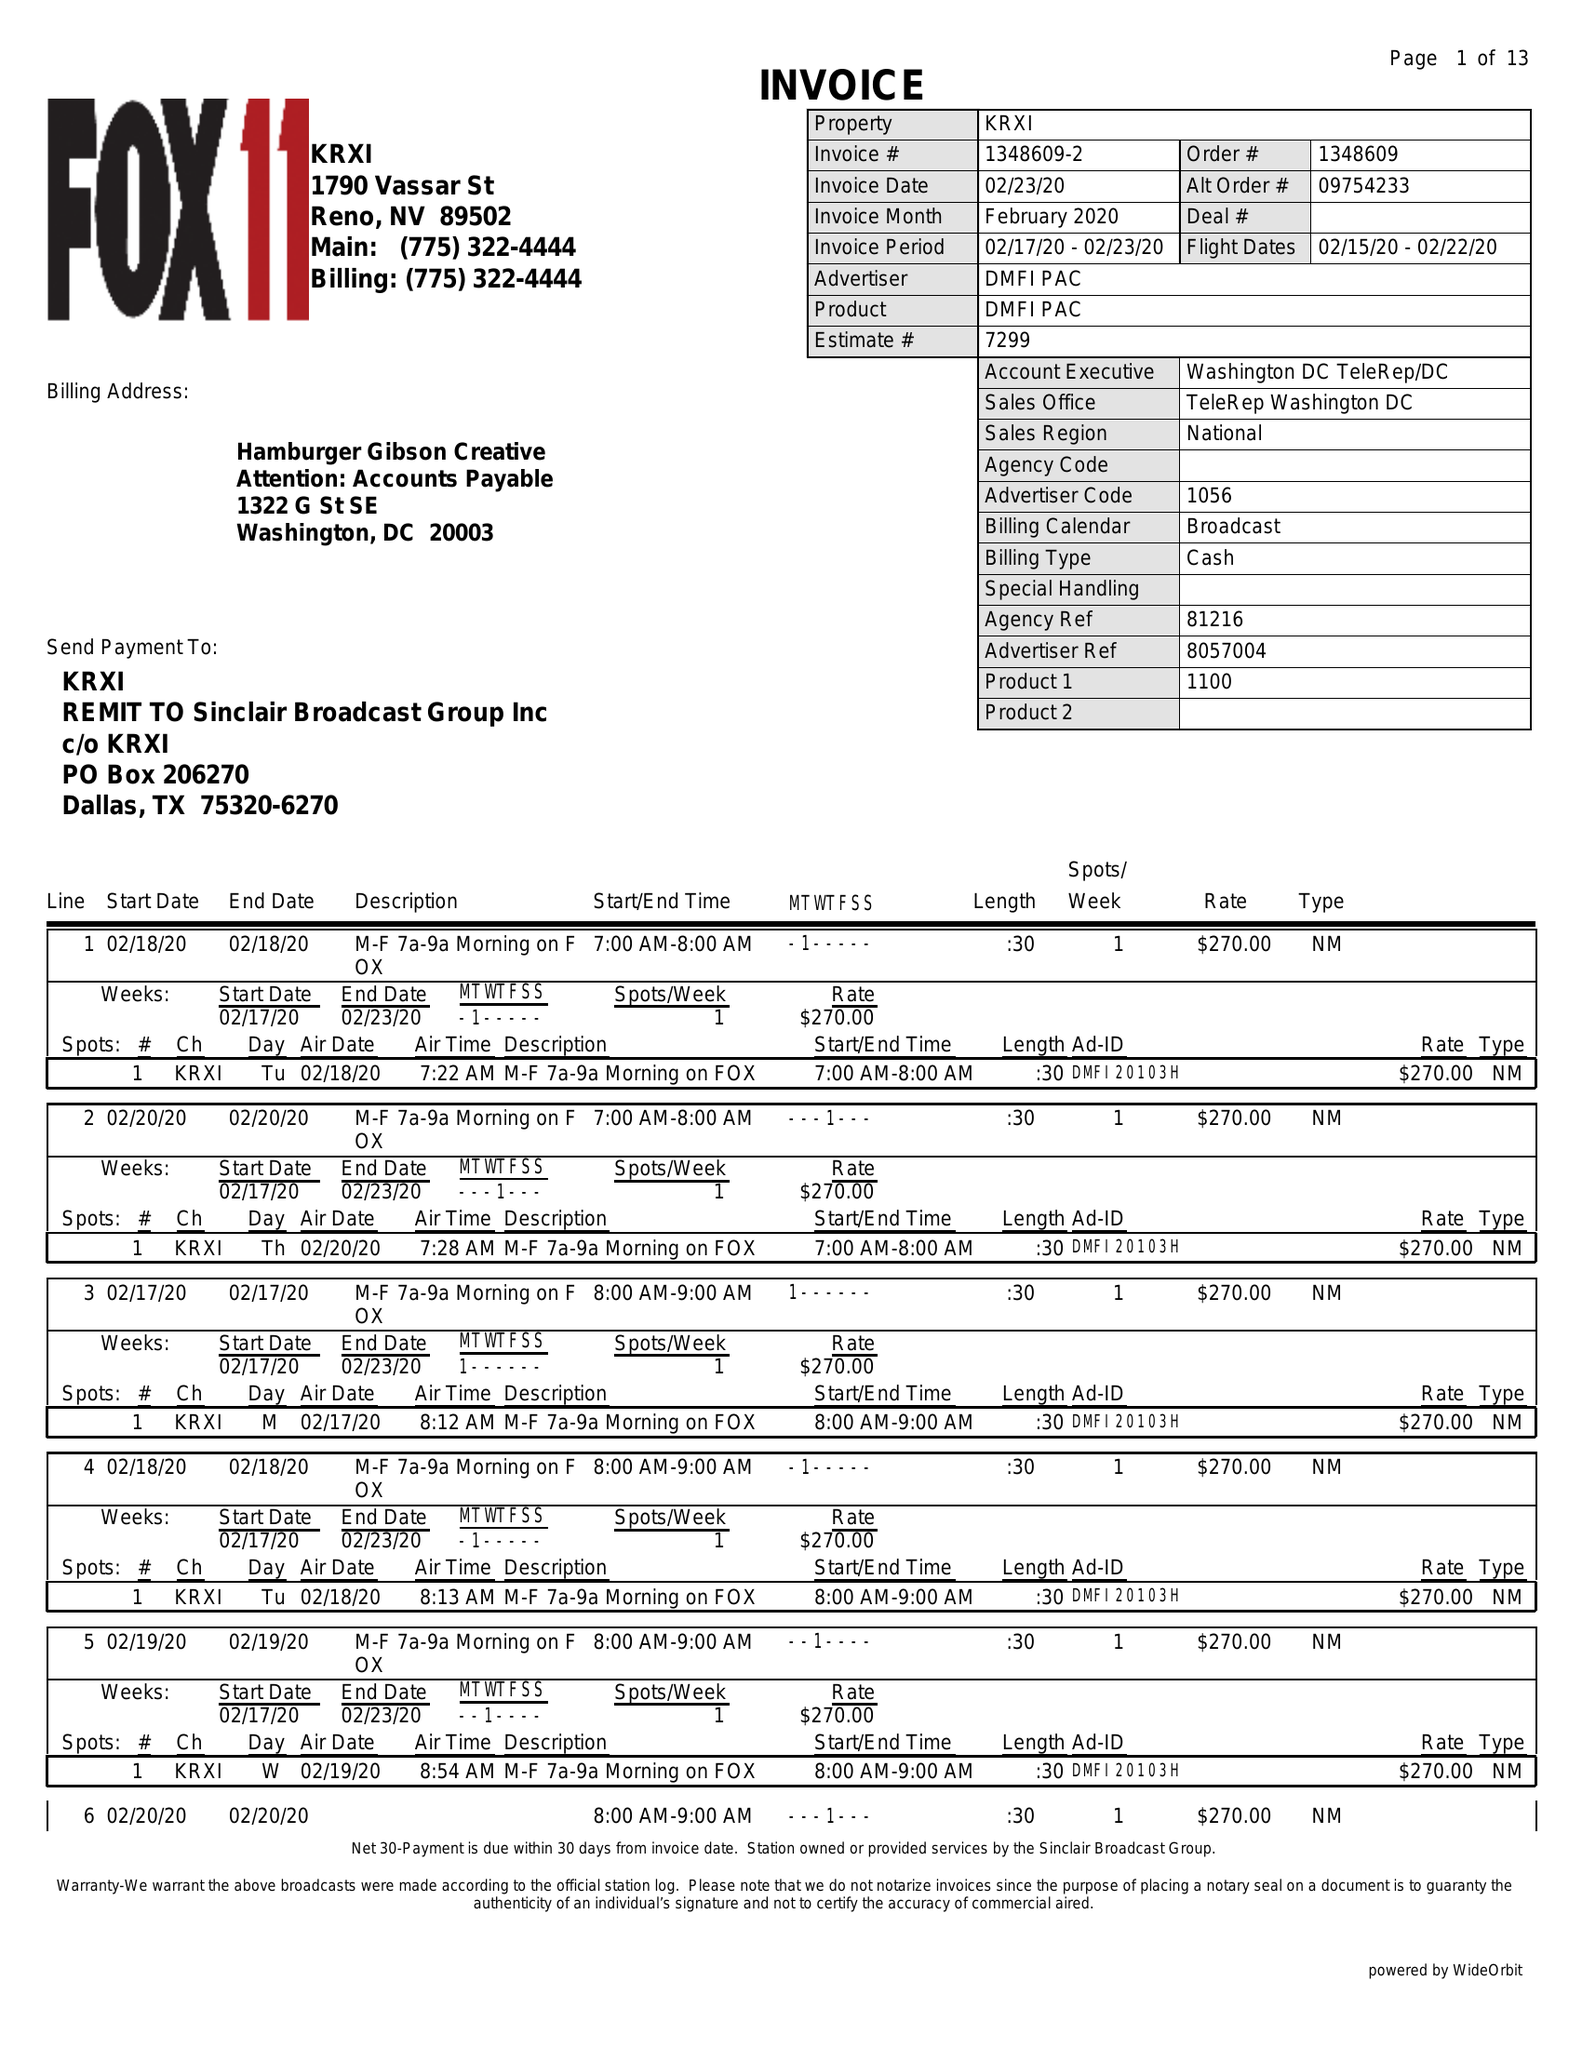What is the value for the contract_num?
Answer the question using a single word or phrase. 1348609 